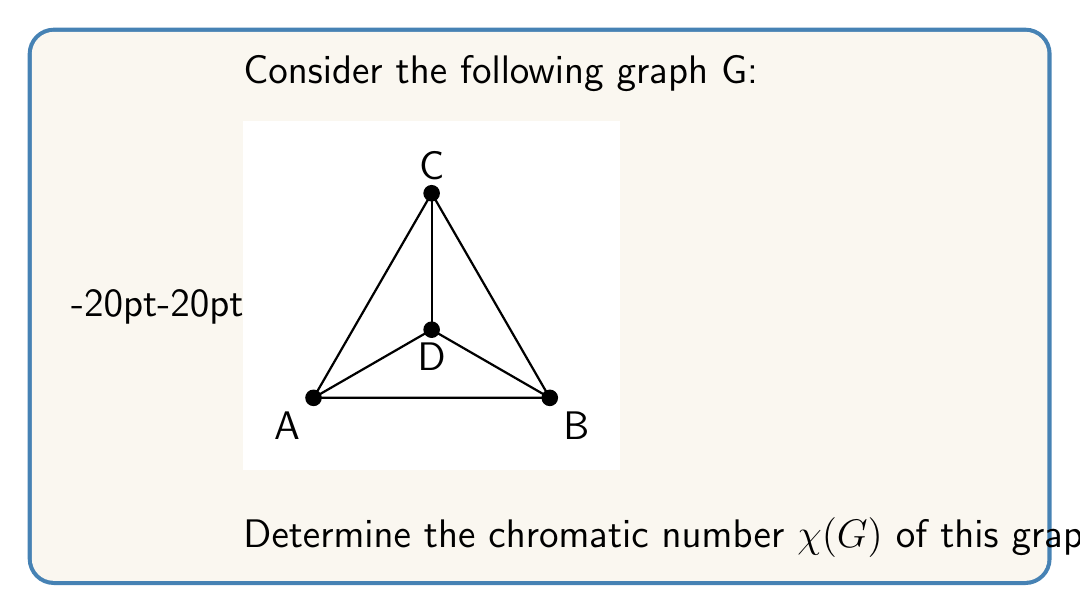Give your solution to this math problem. To determine the chromatic number of the given graph, we'll follow these steps:

1) First, observe that the graph has 4 vertices (A, B, C, D) and forms a complete graph K3 (A-B-C) with an additional vertex (D) connected to all vertices of the K3.

2) We know that a complete graph Kn requires n colors, so the subgraph A-B-C already requires 3 colors.

3) Now, let's try to color vertex D:
   - D is connected to A, B, and C, so it cannot use any of their colors.
   - This means we need a 4th color for D.

4) Therefore, we need at least 4 colors to properly color this graph.

5) We can verify that 4 colors are sufficient:
   - Assign color 1 to A
   - Assign color 2 to B
   - Assign color 3 to C
   - Assign color 4 to D

6) This coloring ensures no two adjacent vertices have the same color.

7) By the definition of chromatic number, $\chi(G)$ is the minimum number of colors needed to color the graph such that no two adjacent vertices have the same color.

Therefore, the chromatic number of this graph is 4.
Answer: $\chi(G) = 4$ 